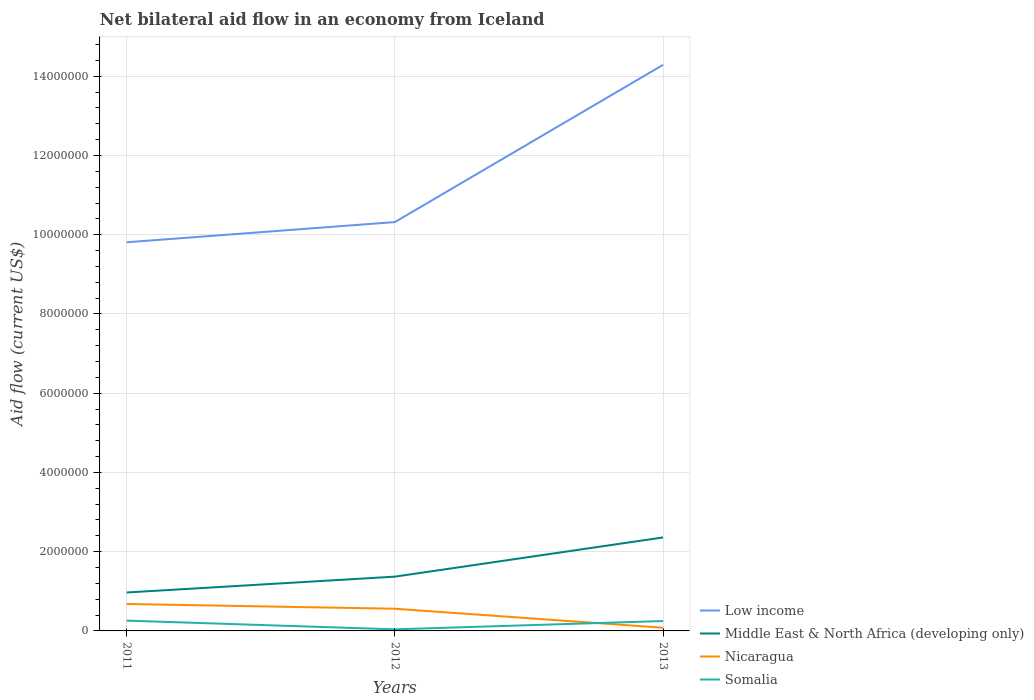How many different coloured lines are there?
Give a very brief answer. 4. Does the line corresponding to Nicaragua intersect with the line corresponding to Somalia?
Ensure brevity in your answer.  Yes. Across all years, what is the maximum net bilateral aid flow in Middle East & North Africa (developing only)?
Ensure brevity in your answer.  9.70e+05. What is the difference between the highest and the second highest net bilateral aid flow in Somalia?
Your answer should be compact. 2.20e+05. What is the difference between the highest and the lowest net bilateral aid flow in Nicaragua?
Ensure brevity in your answer.  2. Is the net bilateral aid flow in Somalia strictly greater than the net bilateral aid flow in Nicaragua over the years?
Provide a succinct answer. No. How many lines are there?
Offer a very short reply. 4. Are the values on the major ticks of Y-axis written in scientific E-notation?
Your answer should be very brief. No. Does the graph contain grids?
Keep it short and to the point. Yes. How are the legend labels stacked?
Provide a succinct answer. Vertical. What is the title of the graph?
Your answer should be very brief. Net bilateral aid flow in an economy from Iceland. What is the Aid flow (current US$) of Low income in 2011?
Your response must be concise. 9.81e+06. What is the Aid flow (current US$) of Middle East & North Africa (developing only) in 2011?
Provide a succinct answer. 9.70e+05. What is the Aid flow (current US$) in Nicaragua in 2011?
Provide a succinct answer. 6.80e+05. What is the Aid flow (current US$) in Low income in 2012?
Keep it short and to the point. 1.03e+07. What is the Aid flow (current US$) of Middle East & North Africa (developing only) in 2012?
Provide a succinct answer. 1.37e+06. What is the Aid flow (current US$) of Nicaragua in 2012?
Make the answer very short. 5.60e+05. What is the Aid flow (current US$) of Somalia in 2012?
Keep it short and to the point. 4.00e+04. What is the Aid flow (current US$) in Low income in 2013?
Make the answer very short. 1.43e+07. What is the Aid flow (current US$) of Middle East & North Africa (developing only) in 2013?
Offer a terse response. 2.36e+06. What is the Aid flow (current US$) of Somalia in 2013?
Provide a succinct answer. 2.50e+05. Across all years, what is the maximum Aid flow (current US$) of Low income?
Offer a terse response. 1.43e+07. Across all years, what is the maximum Aid flow (current US$) in Middle East & North Africa (developing only)?
Offer a terse response. 2.36e+06. Across all years, what is the maximum Aid flow (current US$) of Nicaragua?
Your answer should be compact. 6.80e+05. Across all years, what is the maximum Aid flow (current US$) of Somalia?
Make the answer very short. 2.60e+05. Across all years, what is the minimum Aid flow (current US$) in Low income?
Your response must be concise. 9.81e+06. Across all years, what is the minimum Aid flow (current US$) in Middle East & North Africa (developing only)?
Ensure brevity in your answer.  9.70e+05. Across all years, what is the minimum Aid flow (current US$) in Somalia?
Provide a succinct answer. 4.00e+04. What is the total Aid flow (current US$) of Low income in the graph?
Ensure brevity in your answer.  3.44e+07. What is the total Aid flow (current US$) in Middle East & North Africa (developing only) in the graph?
Offer a terse response. 4.70e+06. What is the total Aid flow (current US$) of Nicaragua in the graph?
Provide a short and direct response. 1.32e+06. What is the total Aid flow (current US$) of Somalia in the graph?
Your answer should be compact. 5.50e+05. What is the difference between the Aid flow (current US$) of Low income in 2011 and that in 2012?
Your response must be concise. -5.10e+05. What is the difference between the Aid flow (current US$) in Middle East & North Africa (developing only) in 2011 and that in 2012?
Offer a terse response. -4.00e+05. What is the difference between the Aid flow (current US$) in Somalia in 2011 and that in 2012?
Make the answer very short. 2.20e+05. What is the difference between the Aid flow (current US$) of Low income in 2011 and that in 2013?
Your response must be concise. -4.48e+06. What is the difference between the Aid flow (current US$) in Middle East & North Africa (developing only) in 2011 and that in 2013?
Make the answer very short. -1.39e+06. What is the difference between the Aid flow (current US$) in Nicaragua in 2011 and that in 2013?
Provide a succinct answer. 6.00e+05. What is the difference between the Aid flow (current US$) in Low income in 2012 and that in 2013?
Ensure brevity in your answer.  -3.97e+06. What is the difference between the Aid flow (current US$) in Middle East & North Africa (developing only) in 2012 and that in 2013?
Your answer should be very brief. -9.90e+05. What is the difference between the Aid flow (current US$) in Somalia in 2012 and that in 2013?
Give a very brief answer. -2.10e+05. What is the difference between the Aid flow (current US$) of Low income in 2011 and the Aid flow (current US$) of Middle East & North Africa (developing only) in 2012?
Your response must be concise. 8.44e+06. What is the difference between the Aid flow (current US$) in Low income in 2011 and the Aid flow (current US$) in Nicaragua in 2012?
Provide a succinct answer. 9.25e+06. What is the difference between the Aid flow (current US$) in Low income in 2011 and the Aid flow (current US$) in Somalia in 2012?
Offer a very short reply. 9.77e+06. What is the difference between the Aid flow (current US$) in Middle East & North Africa (developing only) in 2011 and the Aid flow (current US$) in Nicaragua in 2012?
Your answer should be compact. 4.10e+05. What is the difference between the Aid flow (current US$) of Middle East & North Africa (developing only) in 2011 and the Aid flow (current US$) of Somalia in 2012?
Provide a short and direct response. 9.30e+05. What is the difference between the Aid flow (current US$) in Nicaragua in 2011 and the Aid flow (current US$) in Somalia in 2012?
Your response must be concise. 6.40e+05. What is the difference between the Aid flow (current US$) of Low income in 2011 and the Aid flow (current US$) of Middle East & North Africa (developing only) in 2013?
Your answer should be compact. 7.45e+06. What is the difference between the Aid flow (current US$) of Low income in 2011 and the Aid flow (current US$) of Nicaragua in 2013?
Your response must be concise. 9.73e+06. What is the difference between the Aid flow (current US$) of Low income in 2011 and the Aid flow (current US$) of Somalia in 2013?
Ensure brevity in your answer.  9.56e+06. What is the difference between the Aid flow (current US$) in Middle East & North Africa (developing only) in 2011 and the Aid flow (current US$) in Nicaragua in 2013?
Ensure brevity in your answer.  8.90e+05. What is the difference between the Aid flow (current US$) in Middle East & North Africa (developing only) in 2011 and the Aid flow (current US$) in Somalia in 2013?
Your response must be concise. 7.20e+05. What is the difference between the Aid flow (current US$) in Low income in 2012 and the Aid flow (current US$) in Middle East & North Africa (developing only) in 2013?
Provide a succinct answer. 7.96e+06. What is the difference between the Aid flow (current US$) in Low income in 2012 and the Aid flow (current US$) in Nicaragua in 2013?
Your response must be concise. 1.02e+07. What is the difference between the Aid flow (current US$) in Low income in 2012 and the Aid flow (current US$) in Somalia in 2013?
Your response must be concise. 1.01e+07. What is the difference between the Aid flow (current US$) of Middle East & North Africa (developing only) in 2012 and the Aid flow (current US$) of Nicaragua in 2013?
Offer a very short reply. 1.29e+06. What is the difference between the Aid flow (current US$) in Middle East & North Africa (developing only) in 2012 and the Aid flow (current US$) in Somalia in 2013?
Ensure brevity in your answer.  1.12e+06. What is the difference between the Aid flow (current US$) of Nicaragua in 2012 and the Aid flow (current US$) of Somalia in 2013?
Your answer should be very brief. 3.10e+05. What is the average Aid flow (current US$) of Low income per year?
Provide a short and direct response. 1.15e+07. What is the average Aid flow (current US$) in Middle East & North Africa (developing only) per year?
Keep it short and to the point. 1.57e+06. What is the average Aid flow (current US$) in Somalia per year?
Your response must be concise. 1.83e+05. In the year 2011, what is the difference between the Aid flow (current US$) in Low income and Aid flow (current US$) in Middle East & North Africa (developing only)?
Your answer should be very brief. 8.84e+06. In the year 2011, what is the difference between the Aid flow (current US$) of Low income and Aid flow (current US$) of Nicaragua?
Offer a terse response. 9.13e+06. In the year 2011, what is the difference between the Aid flow (current US$) in Low income and Aid flow (current US$) in Somalia?
Your answer should be compact. 9.55e+06. In the year 2011, what is the difference between the Aid flow (current US$) of Middle East & North Africa (developing only) and Aid flow (current US$) of Nicaragua?
Keep it short and to the point. 2.90e+05. In the year 2011, what is the difference between the Aid flow (current US$) in Middle East & North Africa (developing only) and Aid flow (current US$) in Somalia?
Your answer should be compact. 7.10e+05. In the year 2012, what is the difference between the Aid flow (current US$) of Low income and Aid flow (current US$) of Middle East & North Africa (developing only)?
Ensure brevity in your answer.  8.95e+06. In the year 2012, what is the difference between the Aid flow (current US$) in Low income and Aid flow (current US$) in Nicaragua?
Provide a short and direct response. 9.76e+06. In the year 2012, what is the difference between the Aid flow (current US$) of Low income and Aid flow (current US$) of Somalia?
Keep it short and to the point. 1.03e+07. In the year 2012, what is the difference between the Aid flow (current US$) in Middle East & North Africa (developing only) and Aid flow (current US$) in Nicaragua?
Make the answer very short. 8.10e+05. In the year 2012, what is the difference between the Aid flow (current US$) in Middle East & North Africa (developing only) and Aid flow (current US$) in Somalia?
Keep it short and to the point. 1.33e+06. In the year 2012, what is the difference between the Aid flow (current US$) of Nicaragua and Aid flow (current US$) of Somalia?
Provide a succinct answer. 5.20e+05. In the year 2013, what is the difference between the Aid flow (current US$) of Low income and Aid flow (current US$) of Middle East & North Africa (developing only)?
Offer a very short reply. 1.19e+07. In the year 2013, what is the difference between the Aid flow (current US$) of Low income and Aid flow (current US$) of Nicaragua?
Provide a short and direct response. 1.42e+07. In the year 2013, what is the difference between the Aid flow (current US$) of Low income and Aid flow (current US$) of Somalia?
Your response must be concise. 1.40e+07. In the year 2013, what is the difference between the Aid flow (current US$) in Middle East & North Africa (developing only) and Aid flow (current US$) in Nicaragua?
Make the answer very short. 2.28e+06. In the year 2013, what is the difference between the Aid flow (current US$) of Middle East & North Africa (developing only) and Aid flow (current US$) of Somalia?
Your response must be concise. 2.11e+06. In the year 2013, what is the difference between the Aid flow (current US$) of Nicaragua and Aid flow (current US$) of Somalia?
Ensure brevity in your answer.  -1.70e+05. What is the ratio of the Aid flow (current US$) in Low income in 2011 to that in 2012?
Provide a succinct answer. 0.95. What is the ratio of the Aid flow (current US$) in Middle East & North Africa (developing only) in 2011 to that in 2012?
Offer a very short reply. 0.71. What is the ratio of the Aid flow (current US$) of Nicaragua in 2011 to that in 2012?
Provide a short and direct response. 1.21. What is the ratio of the Aid flow (current US$) of Low income in 2011 to that in 2013?
Your response must be concise. 0.69. What is the ratio of the Aid flow (current US$) in Middle East & North Africa (developing only) in 2011 to that in 2013?
Keep it short and to the point. 0.41. What is the ratio of the Aid flow (current US$) in Nicaragua in 2011 to that in 2013?
Your answer should be very brief. 8.5. What is the ratio of the Aid flow (current US$) of Somalia in 2011 to that in 2013?
Give a very brief answer. 1.04. What is the ratio of the Aid flow (current US$) in Low income in 2012 to that in 2013?
Ensure brevity in your answer.  0.72. What is the ratio of the Aid flow (current US$) of Middle East & North Africa (developing only) in 2012 to that in 2013?
Make the answer very short. 0.58. What is the ratio of the Aid flow (current US$) of Somalia in 2012 to that in 2013?
Keep it short and to the point. 0.16. What is the difference between the highest and the second highest Aid flow (current US$) of Low income?
Give a very brief answer. 3.97e+06. What is the difference between the highest and the second highest Aid flow (current US$) of Middle East & North Africa (developing only)?
Provide a short and direct response. 9.90e+05. What is the difference between the highest and the lowest Aid flow (current US$) in Low income?
Offer a terse response. 4.48e+06. What is the difference between the highest and the lowest Aid flow (current US$) in Middle East & North Africa (developing only)?
Your answer should be very brief. 1.39e+06. 